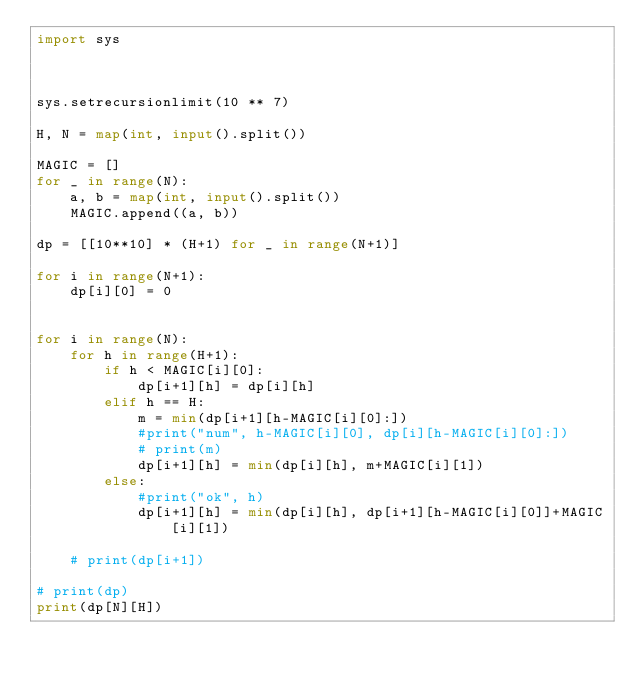<code> <loc_0><loc_0><loc_500><loc_500><_Python_>import sys



sys.setrecursionlimit(10 ** 7)

H, N = map(int, input().split())

MAGIC = []
for _ in range(N):
    a, b = map(int, input().split())
    MAGIC.append((a, b))

dp = [[10**10] * (H+1) for _ in range(N+1)]

for i in range(N+1):
    dp[i][0] = 0


for i in range(N):
    for h in range(H+1):
        if h < MAGIC[i][0]:
            dp[i+1][h] = dp[i][h]
        elif h == H:
            m = min(dp[i+1][h-MAGIC[i][0]:])
            #print("num", h-MAGIC[i][0], dp[i][h-MAGIC[i][0]:])
            # print(m)
            dp[i+1][h] = min(dp[i][h], m+MAGIC[i][1])
        else:
            #print("ok", h)
            dp[i+1][h] = min(dp[i][h], dp[i+1][h-MAGIC[i][0]]+MAGIC[i][1])

    # print(dp[i+1])

# print(dp)
print(dp[N][H])
</code> 